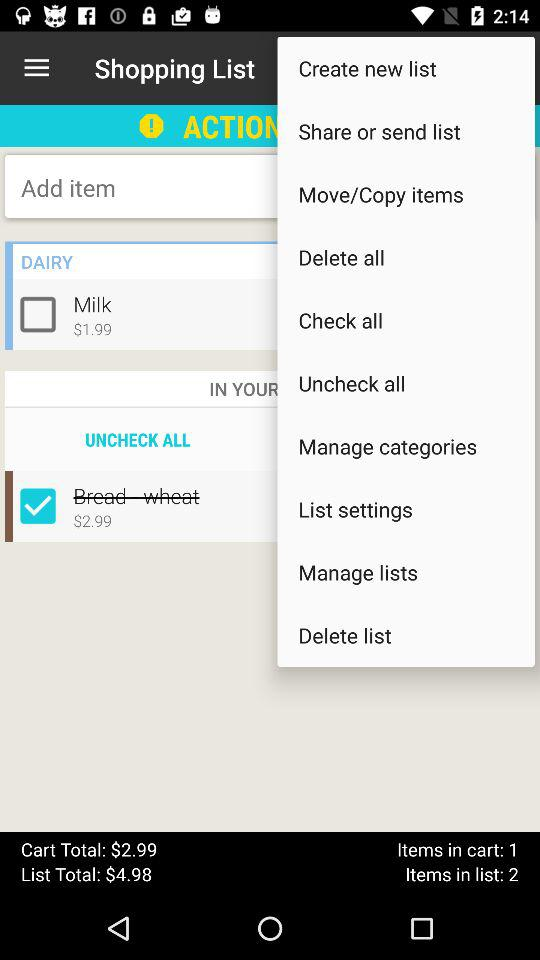How many items are in the cart? There is 1 item in the cart. 